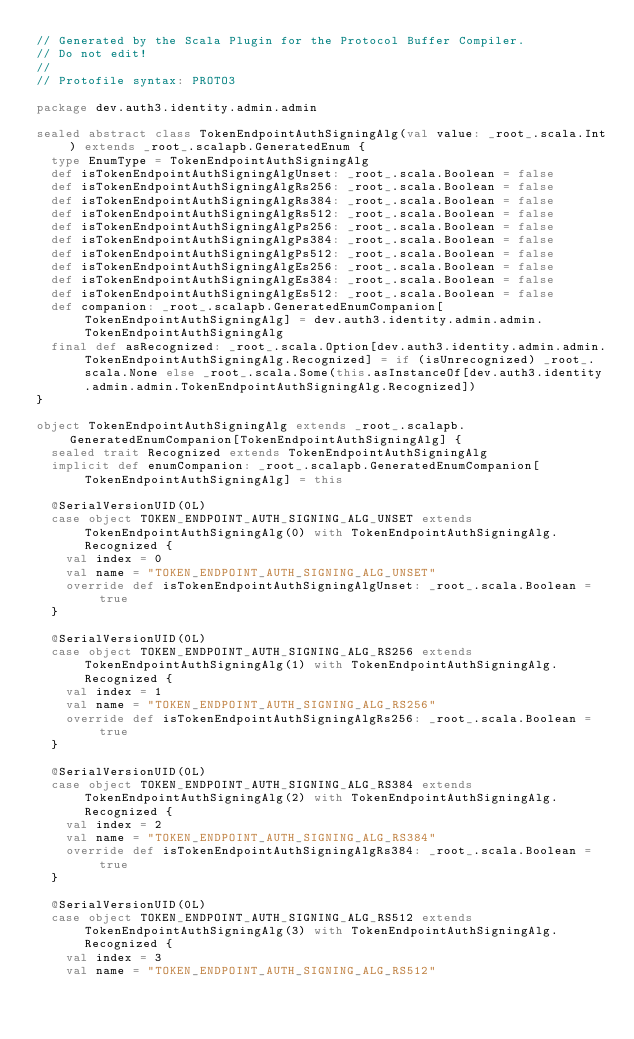<code> <loc_0><loc_0><loc_500><loc_500><_Scala_>// Generated by the Scala Plugin for the Protocol Buffer Compiler.
// Do not edit!
//
// Protofile syntax: PROTO3

package dev.auth3.identity.admin.admin

sealed abstract class TokenEndpointAuthSigningAlg(val value: _root_.scala.Int) extends _root_.scalapb.GeneratedEnum {
  type EnumType = TokenEndpointAuthSigningAlg
  def isTokenEndpointAuthSigningAlgUnset: _root_.scala.Boolean = false
  def isTokenEndpointAuthSigningAlgRs256: _root_.scala.Boolean = false
  def isTokenEndpointAuthSigningAlgRs384: _root_.scala.Boolean = false
  def isTokenEndpointAuthSigningAlgRs512: _root_.scala.Boolean = false
  def isTokenEndpointAuthSigningAlgPs256: _root_.scala.Boolean = false
  def isTokenEndpointAuthSigningAlgPs384: _root_.scala.Boolean = false
  def isTokenEndpointAuthSigningAlgPs512: _root_.scala.Boolean = false
  def isTokenEndpointAuthSigningAlgEs256: _root_.scala.Boolean = false
  def isTokenEndpointAuthSigningAlgEs384: _root_.scala.Boolean = false
  def isTokenEndpointAuthSigningAlgEs512: _root_.scala.Boolean = false
  def companion: _root_.scalapb.GeneratedEnumCompanion[TokenEndpointAuthSigningAlg] = dev.auth3.identity.admin.admin.TokenEndpointAuthSigningAlg
  final def asRecognized: _root_.scala.Option[dev.auth3.identity.admin.admin.TokenEndpointAuthSigningAlg.Recognized] = if (isUnrecognized) _root_.scala.None else _root_.scala.Some(this.asInstanceOf[dev.auth3.identity.admin.admin.TokenEndpointAuthSigningAlg.Recognized])
}

object TokenEndpointAuthSigningAlg extends _root_.scalapb.GeneratedEnumCompanion[TokenEndpointAuthSigningAlg] {
  sealed trait Recognized extends TokenEndpointAuthSigningAlg
  implicit def enumCompanion: _root_.scalapb.GeneratedEnumCompanion[TokenEndpointAuthSigningAlg] = this
  
  @SerialVersionUID(0L)
  case object TOKEN_ENDPOINT_AUTH_SIGNING_ALG_UNSET extends TokenEndpointAuthSigningAlg(0) with TokenEndpointAuthSigningAlg.Recognized {
    val index = 0
    val name = "TOKEN_ENDPOINT_AUTH_SIGNING_ALG_UNSET"
    override def isTokenEndpointAuthSigningAlgUnset: _root_.scala.Boolean = true
  }
  
  @SerialVersionUID(0L)
  case object TOKEN_ENDPOINT_AUTH_SIGNING_ALG_RS256 extends TokenEndpointAuthSigningAlg(1) with TokenEndpointAuthSigningAlg.Recognized {
    val index = 1
    val name = "TOKEN_ENDPOINT_AUTH_SIGNING_ALG_RS256"
    override def isTokenEndpointAuthSigningAlgRs256: _root_.scala.Boolean = true
  }
  
  @SerialVersionUID(0L)
  case object TOKEN_ENDPOINT_AUTH_SIGNING_ALG_RS384 extends TokenEndpointAuthSigningAlg(2) with TokenEndpointAuthSigningAlg.Recognized {
    val index = 2
    val name = "TOKEN_ENDPOINT_AUTH_SIGNING_ALG_RS384"
    override def isTokenEndpointAuthSigningAlgRs384: _root_.scala.Boolean = true
  }
  
  @SerialVersionUID(0L)
  case object TOKEN_ENDPOINT_AUTH_SIGNING_ALG_RS512 extends TokenEndpointAuthSigningAlg(3) with TokenEndpointAuthSigningAlg.Recognized {
    val index = 3
    val name = "TOKEN_ENDPOINT_AUTH_SIGNING_ALG_RS512"</code> 